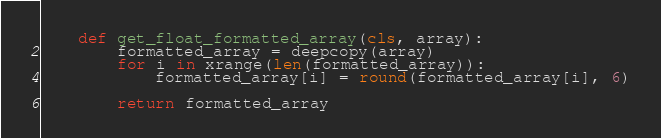<code> <loc_0><loc_0><loc_500><loc_500><_Python_>    def get_float_formatted_array(cls, array):
        formatted_array = deepcopy(array)
        for i in xrange(len(formatted_array)):
            formatted_array[i] = round(formatted_array[i], 6)

        return formatted_array</code> 